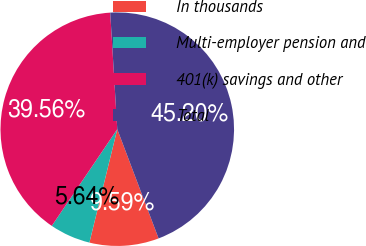Convert chart. <chart><loc_0><loc_0><loc_500><loc_500><pie_chart><fcel>In thousands<fcel>Multi-employer pension and<fcel>401(k) savings and other<fcel>Total<nl><fcel>9.59%<fcel>5.64%<fcel>39.56%<fcel>45.2%<nl></chart> 